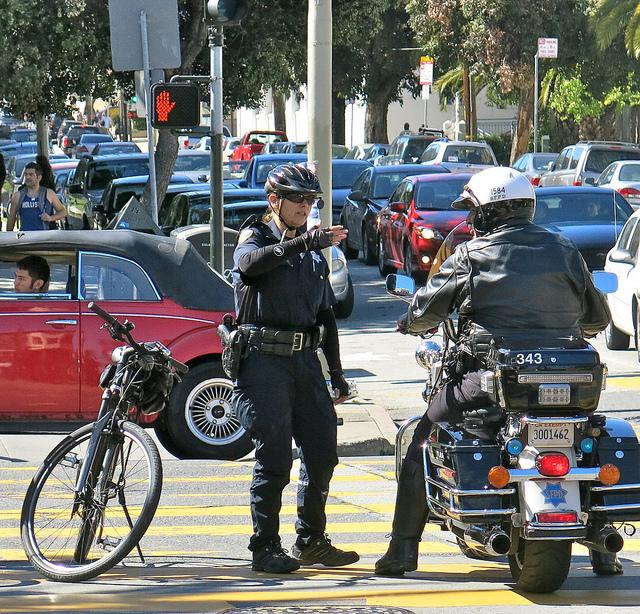What are they discussing? traffic 